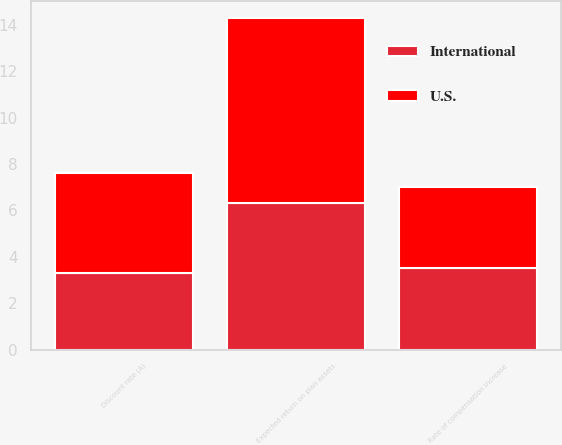<chart> <loc_0><loc_0><loc_500><loc_500><stacked_bar_chart><ecel><fcel>Discount rate (A)<fcel>Expected return on plan assets<fcel>Rate of compensation increase<nl><fcel>U.S.<fcel>4.3<fcel>8<fcel>3.5<nl><fcel>International<fcel>3.3<fcel>6.3<fcel>3.5<nl></chart> 